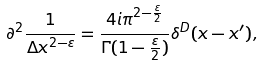<formula> <loc_0><loc_0><loc_500><loc_500>\partial ^ { 2 } \frac { 1 } { \Delta x ^ { 2 - \varepsilon } } = \frac { 4 i \pi ^ { 2 - \frac { \varepsilon } { 2 } } } { \Gamma ( 1 - \frac { \varepsilon } { 2 } ) } \delta ^ { D } ( x - x ^ { \prime } ) ,</formula> 